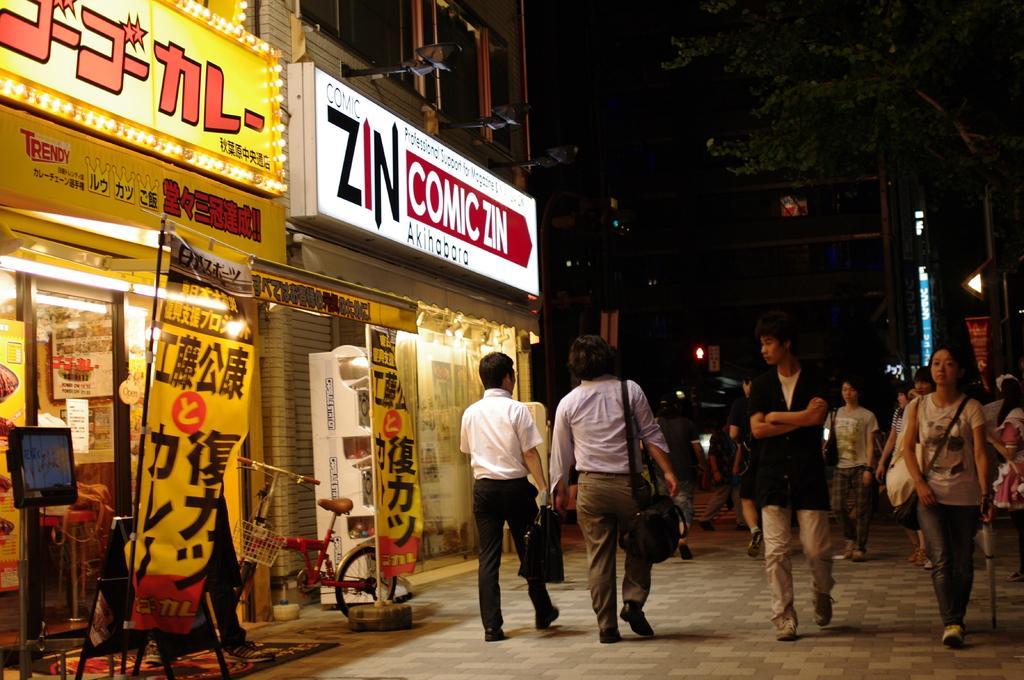How would you summarize this image in a sentence or two? In this picture we can see few people are holding objects in their hands and walking on the path. We can see few posts and a bicycle on the path. There is a building and some lights on the building. We can see a tree and a pole on right side. 